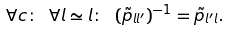<formula> <loc_0><loc_0><loc_500><loc_500>\forall c \colon \ \forall l \simeq l \colon \ ( \tilde { p } _ { l l ^ { \prime } } ) ^ { - 1 } & = \tilde { p } _ { l ^ { \prime } l } .</formula> 